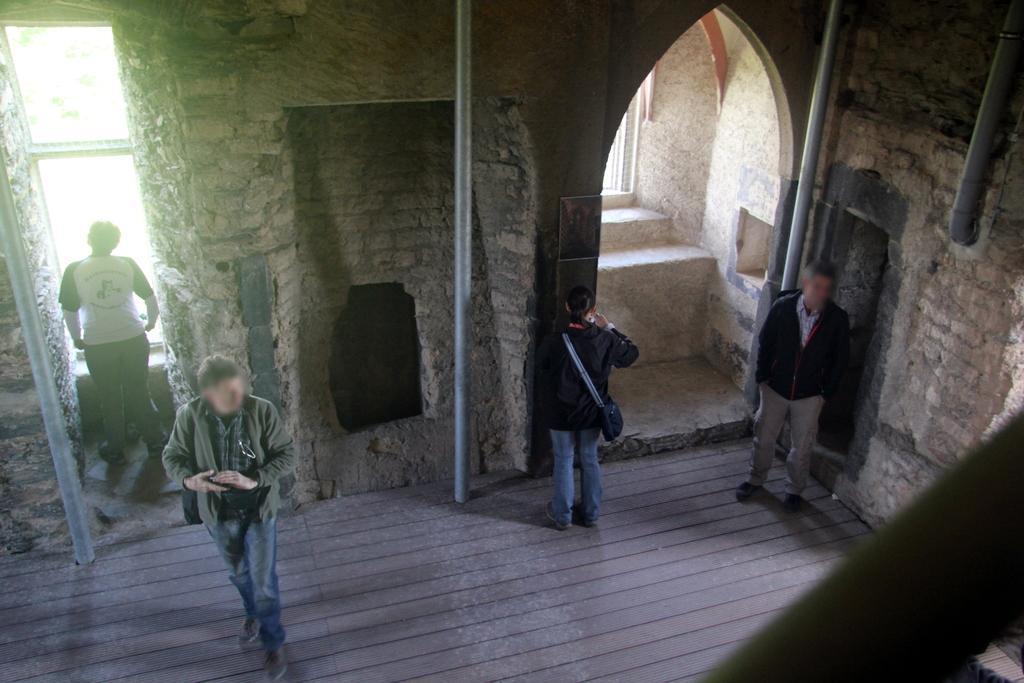Could you give a brief overview of what you see in this image? In the image it seems to be in an old building. On the left side there is a person stood in front of window and man walking in the middle and on right side there is a man stood near wall and a woman starting at wall. 